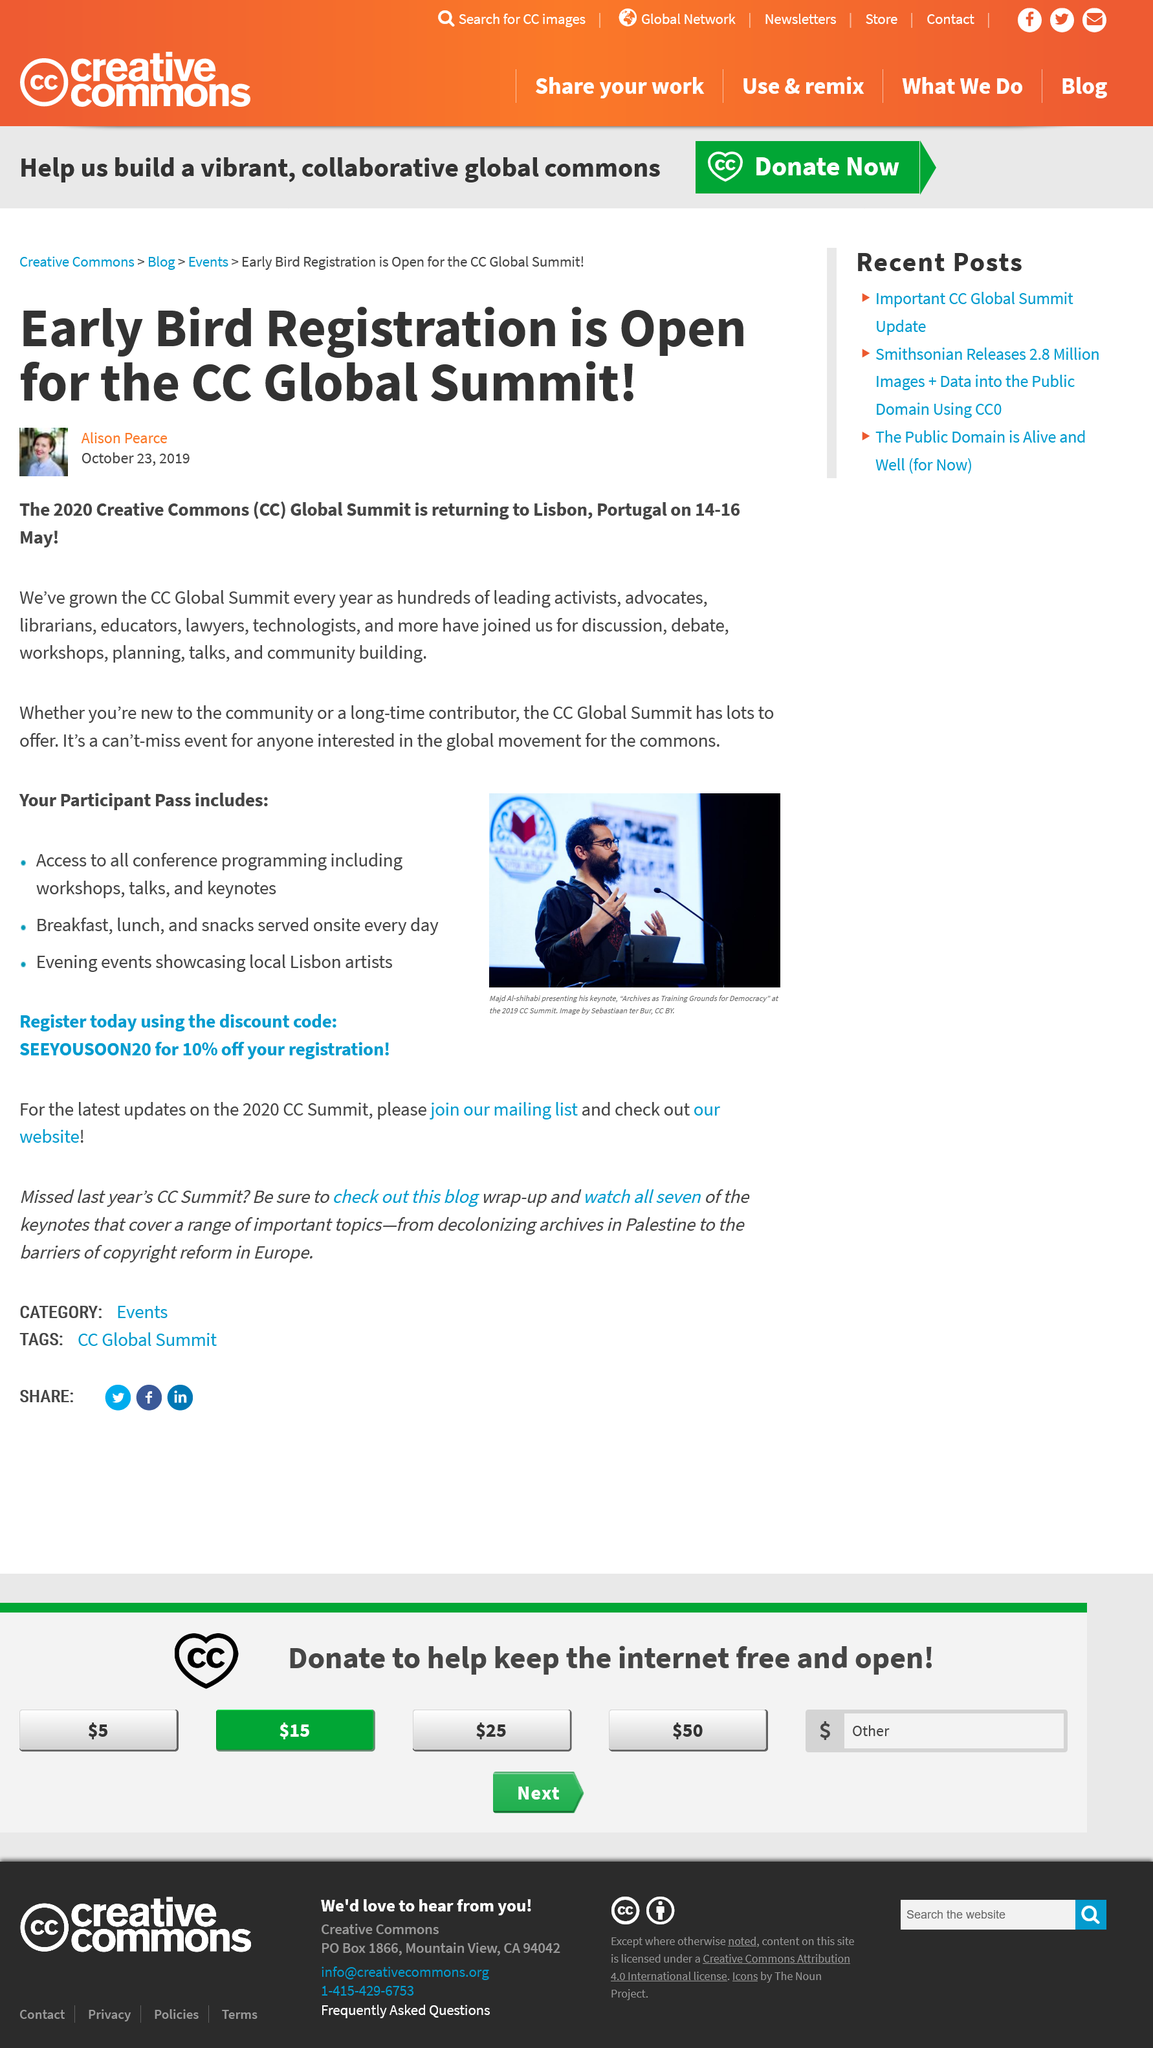Draw attention to some important aspects in this diagram. The CC Global Summit provides opportunities for discussion, debate, workshops, planning, talks, and community building. The 2020 Creative Commons Global Summit is scheduled to take place in Lisbon, Portugal from 14-16 May 2020. The CC Global Summit will be attended by a diverse group of individuals who are leading activists, advocates, librarians, educators, lawyers, and technologists. 